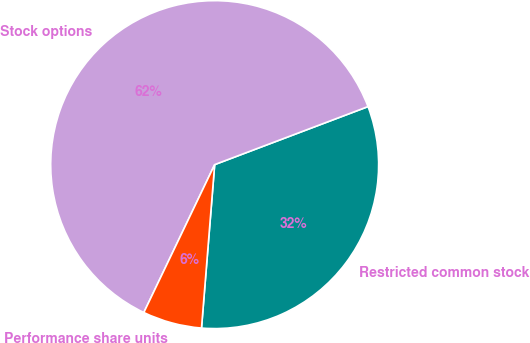Convert chart. <chart><loc_0><loc_0><loc_500><loc_500><pie_chart><fcel>Restricted common stock<fcel>Stock options<fcel>Performance share units<nl><fcel>32.04%<fcel>62.14%<fcel>5.83%<nl></chart> 